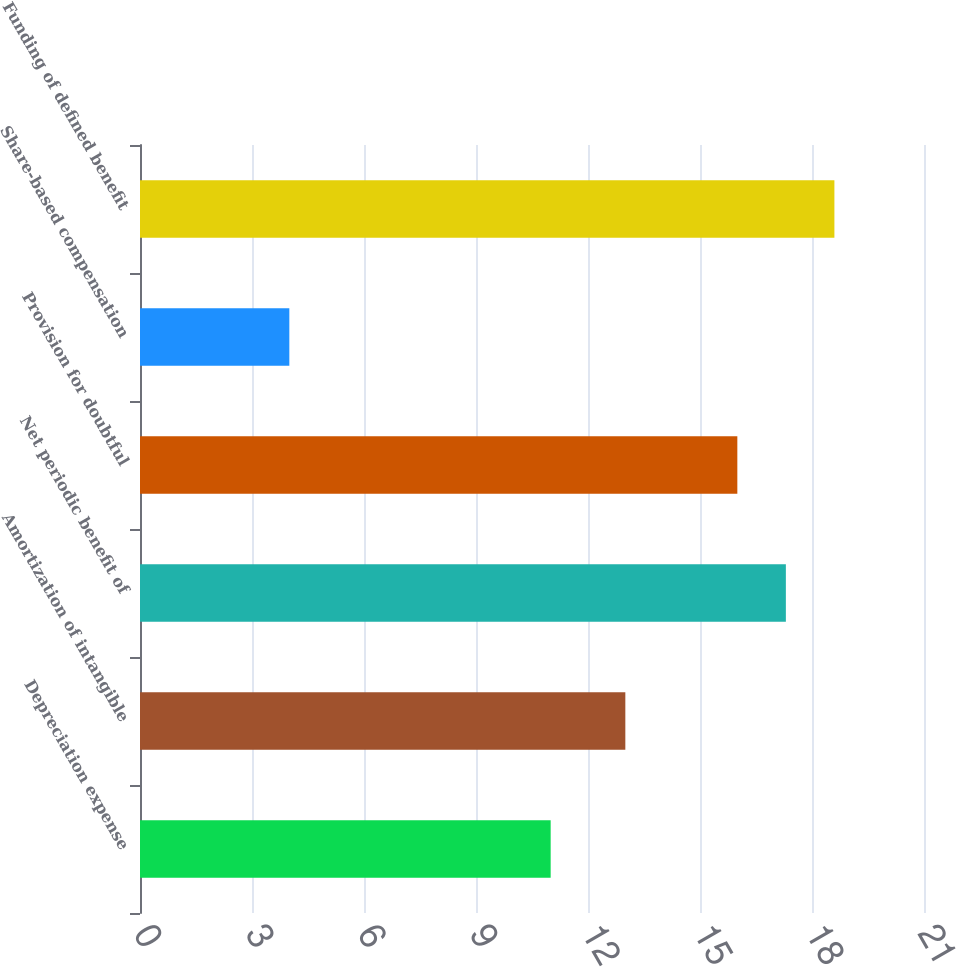<chart> <loc_0><loc_0><loc_500><loc_500><bar_chart><fcel>Depreciation expense<fcel>Amortization of intangible<fcel>Net periodic benefit of<fcel>Provision for doubtful<fcel>Share-based compensation<fcel>Funding of defined benefit<nl><fcel>11<fcel>13<fcel>17.3<fcel>16<fcel>4<fcel>18.6<nl></chart> 